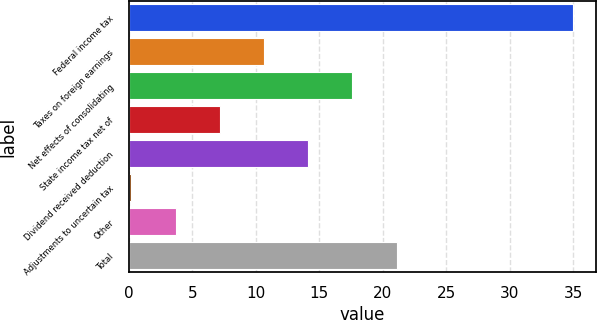Convert chart to OTSL. <chart><loc_0><loc_0><loc_500><loc_500><bar_chart><fcel>Federal income tax<fcel>Taxes on foreign earnings<fcel>Net effects of consolidating<fcel>State income tax net of<fcel>Dividend received deduction<fcel>Adjustments to uncertain tax<fcel>Other<fcel>Total<nl><fcel>35<fcel>10.64<fcel>17.6<fcel>7.16<fcel>14.12<fcel>0.2<fcel>3.68<fcel>21.08<nl></chart> 